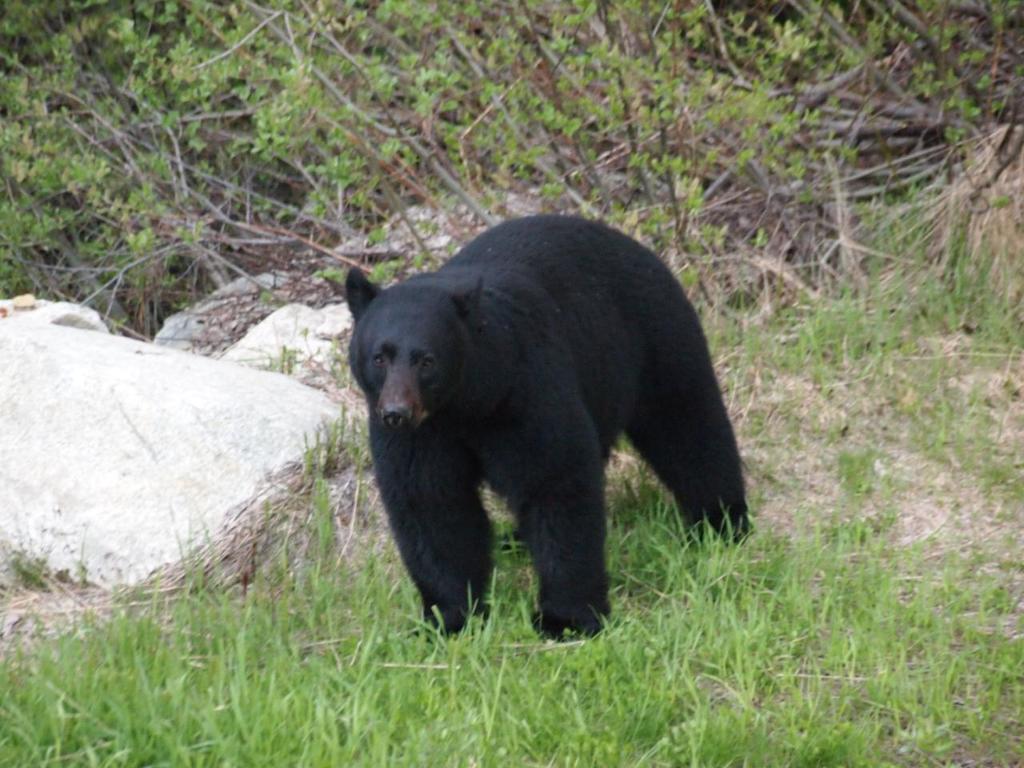Can you describe this image briefly? In this image I can see black color bear is standing on the ground. In the background I can see the grass, rocks and plants. 